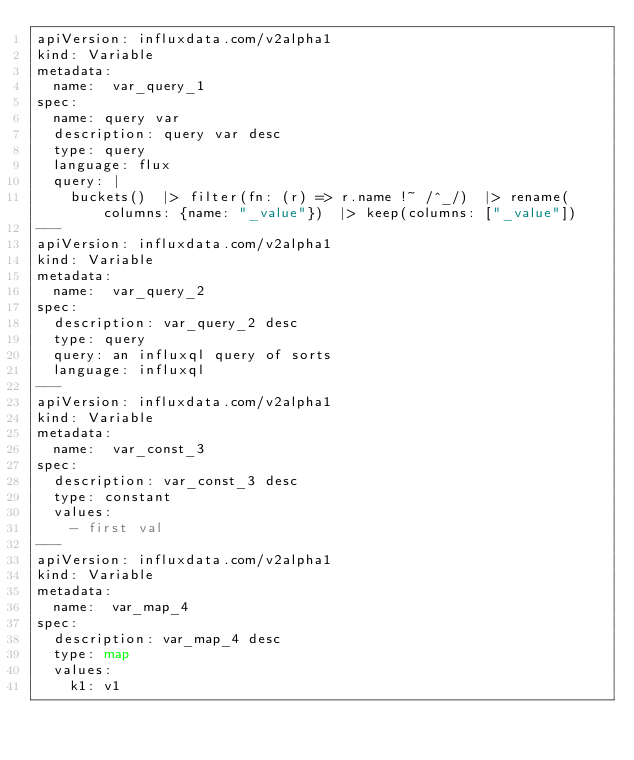<code> <loc_0><loc_0><loc_500><loc_500><_YAML_>apiVersion: influxdata.com/v2alpha1
kind: Variable
metadata:
  name:  var_query_1
spec:
  name: query var
  description: query var desc
  type: query
  language: flux
  query: |
    buckets()  |> filter(fn: (r) => r.name !~ /^_/)  |> rename(columns: {name: "_value"})  |> keep(columns: ["_value"])
---
apiVersion: influxdata.com/v2alpha1
kind: Variable
metadata:
  name:  var_query_2
spec:
  description: var_query_2 desc
  type: query
  query: an influxql query of sorts
  language: influxql
---
apiVersion: influxdata.com/v2alpha1
kind: Variable
metadata:
  name:  var_const_3
spec:
  description: var_const_3 desc
  type: constant
  values:
    - first val
---
apiVersion: influxdata.com/v2alpha1
kind: Variable
metadata:
  name:  var_map_4
spec:
  description: var_map_4 desc
  type: map
  values:
    k1: v1
</code> 